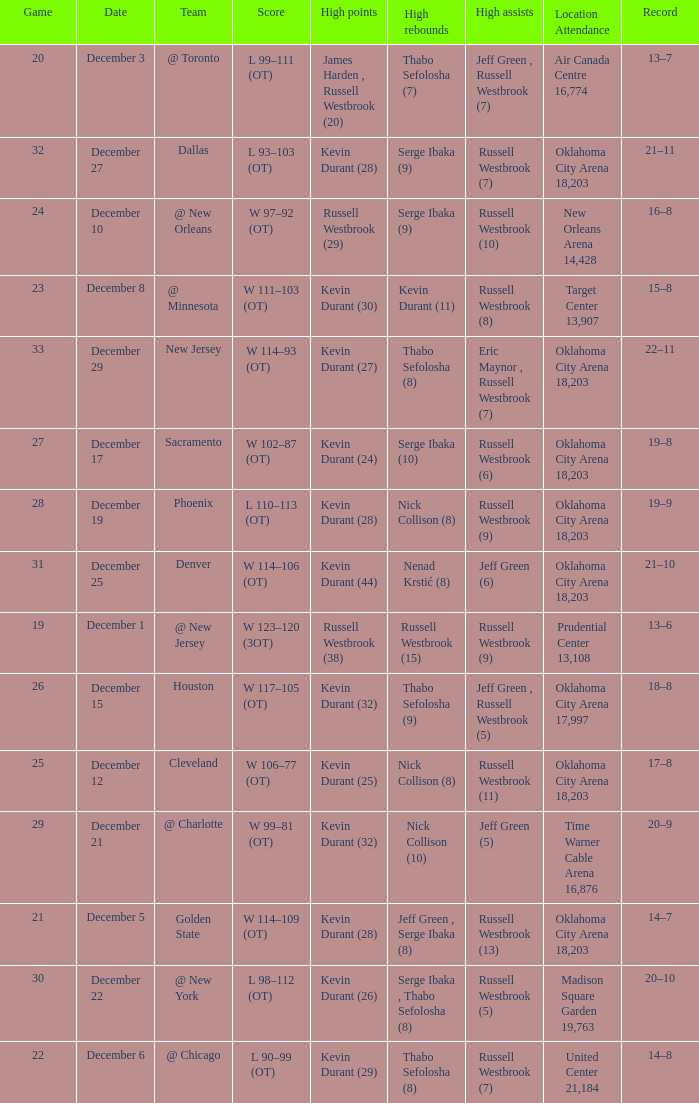Who had the high rebounds record on December 12? Nick Collison (8). 